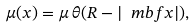Convert formula to latex. <formula><loc_0><loc_0><loc_500><loc_500>\mu ( x ) = \mu \, \theta ( R - | { \ m b f x } | ) ,</formula> 